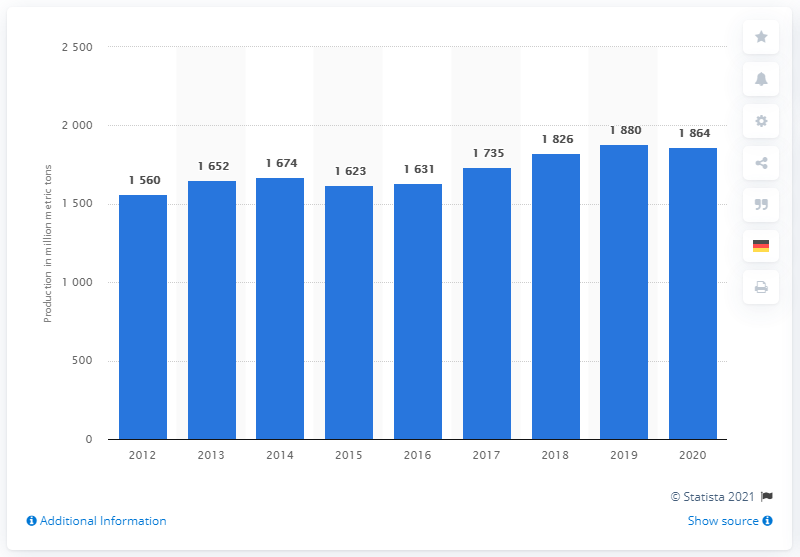Give some essential details in this illustration. In 2020, the world produced a significant amount of crude steel. Specifically, the quantity of crude steel produced worldwide was 1864... In the year 2020, crude steel was produced worldwide. 